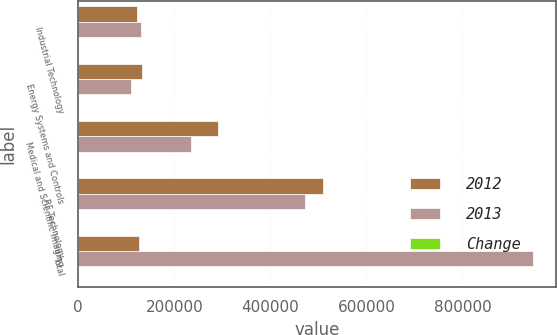<chart> <loc_0><loc_0><loc_500><loc_500><stacked_bar_chart><ecel><fcel>Industrial Technology<fcel>Energy Systems and Controls<fcel>Medical and Scientific Imaging<fcel>RF Technology<fcel>Total<nl><fcel>2012<fcel>121943<fcel>131799<fcel>290435<fcel>510553<fcel>126782<nl><fcel>2013<fcel>131621<fcel>109885<fcel>234526<fcel>471185<fcel>947217<nl><fcel>Change<fcel>7.4<fcel>19.9<fcel>23.8<fcel>8.4<fcel>11.4<nl></chart> 